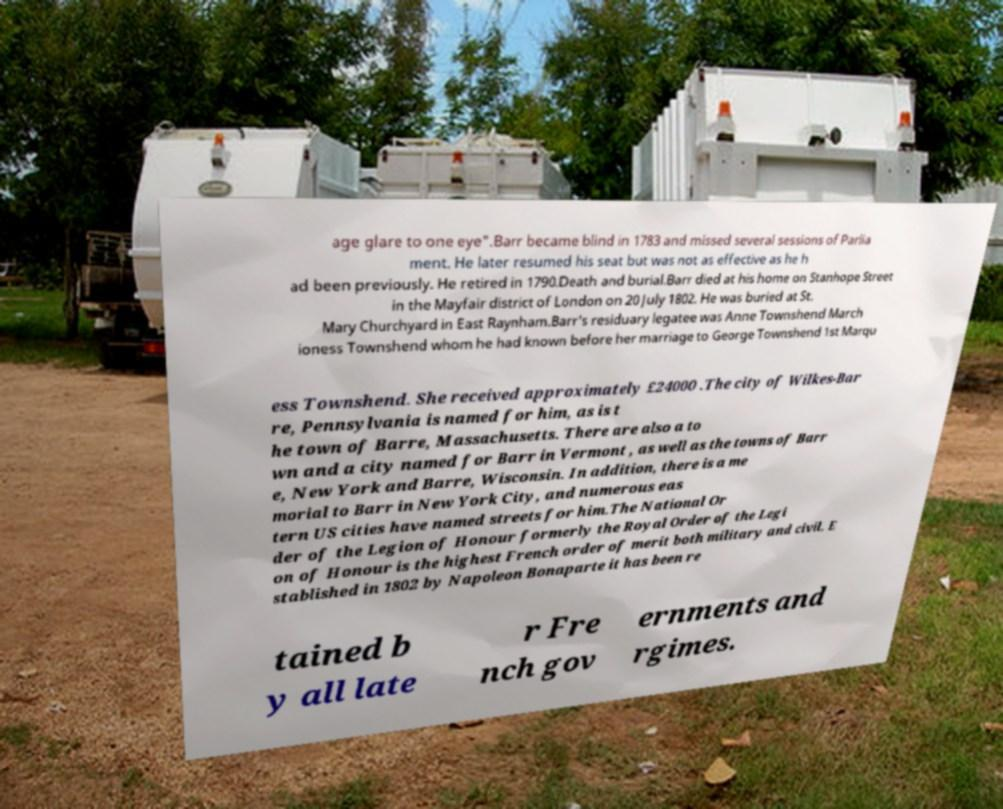What messages or text are displayed in this image? I need them in a readable, typed format. age glare to one eye".Barr became blind in 1783 and missed several sessions of Parlia ment. He later resumed his seat but was not as effective as he h ad been previously. He retired in 1790.Death and burial.Barr died at his home on Stanhope Street in the Mayfair district of London on 20 July 1802. He was buried at St. Mary Churchyard in East Raynham.Barr's residuary legatee was Anne Townshend March ioness Townshend whom he had known before her marriage to George Townshend 1st Marqu ess Townshend. She received approximately £24000 .The city of Wilkes-Bar re, Pennsylvania is named for him, as is t he town of Barre, Massachusetts. There are also a to wn and a city named for Barr in Vermont , as well as the towns of Barr e, New York and Barre, Wisconsin. In addition, there is a me morial to Barr in New York City, and numerous eas tern US cities have named streets for him.The National Or der of the Legion of Honour formerly the Royal Order of the Legi on of Honour is the highest French order of merit both military and civil. E stablished in 1802 by Napoleon Bonaparte it has been re tained b y all late r Fre nch gov ernments and rgimes. 